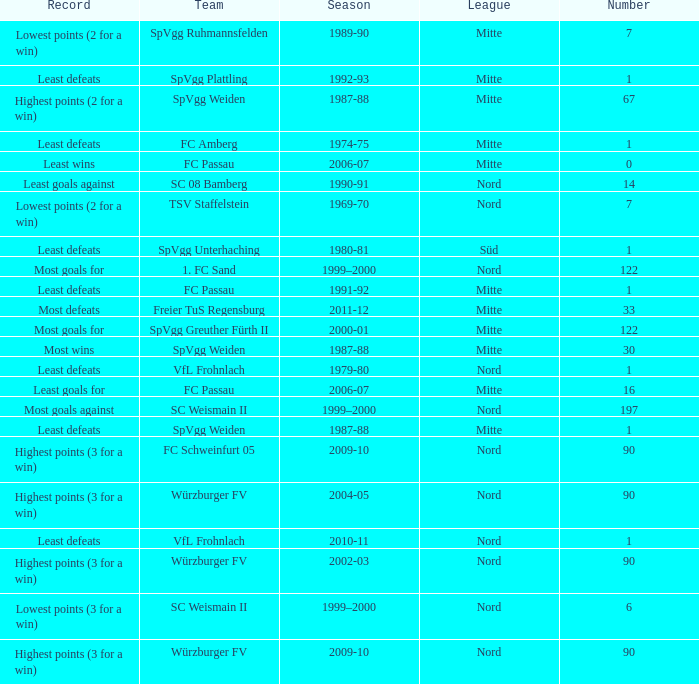What league has a number less than 1? Mitte. 